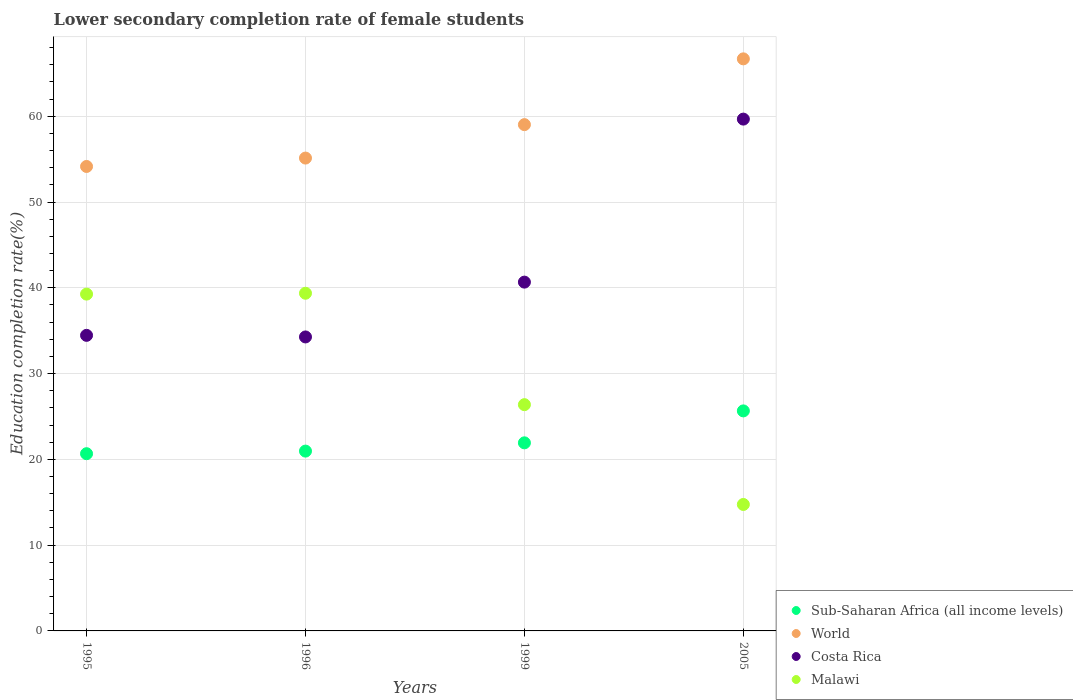Is the number of dotlines equal to the number of legend labels?
Your response must be concise. Yes. What is the lower secondary completion rate of female students in Costa Rica in 1995?
Offer a very short reply. 34.46. Across all years, what is the maximum lower secondary completion rate of female students in Costa Rica?
Your answer should be very brief. 59.67. Across all years, what is the minimum lower secondary completion rate of female students in Sub-Saharan Africa (all income levels)?
Your answer should be very brief. 20.66. In which year was the lower secondary completion rate of female students in Costa Rica maximum?
Make the answer very short. 2005. In which year was the lower secondary completion rate of female students in World minimum?
Ensure brevity in your answer.  1995. What is the total lower secondary completion rate of female students in Sub-Saharan Africa (all income levels) in the graph?
Your response must be concise. 89.2. What is the difference between the lower secondary completion rate of female students in World in 1995 and that in 1996?
Offer a very short reply. -0.98. What is the difference between the lower secondary completion rate of female students in Sub-Saharan Africa (all income levels) in 1995 and the lower secondary completion rate of female students in Costa Rica in 1996?
Your response must be concise. -13.61. What is the average lower secondary completion rate of female students in Malawi per year?
Provide a succinct answer. 29.94. In the year 1995, what is the difference between the lower secondary completion rate of female students in World and lower secondary completion rate of female students in Sub-Saharan Africa (all income levels)?
Offer a terse response. 33.49. In how many years, is the lower secondary completion rate of female students in Malawi greater than 14 %?
Offer a terse response. 4. What is the ratio of the lower secondary completion rate of female students in Malawi in 1995 to that in 2005?
Offer a very short reply. 2.66. What is the difference between the highest and the second highest lower secondary completion rate of female students in Malawi?
Give a very brief answer. 0.1. What is the difference between the highest and the lowest lower secondary completion rate of female students in World?
Provide a succinct answer. 12.54. In how many years, is the lower secondary completion rate of female students in Sub-Saharan Africa (all income levels) greater than the average lower secondary completion rate of female students in Sub-Saharan Africa (all income levels) taken over all years?
Give a very brief answer. 1. Is the sum of the lower secondary completion rate of female students in Malawi in 1995 and 2005 greater than the maximum lower secondary completion rate of female students in Sub-Saharan Africa (all income levels) across all years?
Offer a terse response. Yes. Is the lower secondary completion rate of female students in Malawi strictly greater than the lower secondary completion rate of female students in World over the years?
Provide a succinct answer. No. How many dotlines are there?
Provide a short and direct response. 4. How many years are there in the graph?
Your response must be concise. 4. Does the graph contain any zero values?
Give a very brief answer. No. Does the graph contain grids?
Provide a succinct answer. Yes. Where does the legend appear in the graph?
Offer a very short reply. Bottom right. How many legend labels are there?
Your answer should be compact. 4. What is the title of the graph?
Give a very brief answer. Lower secondary completion rate of female students. What is the label or title of the Y-axis?
Your answer should be very brief. Education completion rate(%). What is the Education completion rate(%) in Sub-Saharan Africa (all income levels) in 1995?
Offer a terse response. 20.66. What is the Education completion rate(%) of World in 1995?
Make the answer very short. 54.15. What is the Education completion rate(%) of Costa Rica in 1995?
Offer a very short reply. 34.46. What is the Education completion rate(%) in Malawi in 1995?
Your answer should be compact. 39.27. What is the Education completion rate(%) of Sub-Saharan Africa (all income levels) in 1996?
Make the answer very short. 20.96. What is the Education completion rate(%) in World in 1996?
Offer a very short reply. 55.13. What is the Education completion rate(%) in Costa Rica in 1996?
Provide a succinct answer. 34.27. What is the Education completion rate(%) of Malawi in 1996?
Make the answer very short. 39.37. What is the Education completion rate(%) of Sub-Saharan Africa (all income levels) in 1999?
Give a very brief answer. 21.93. What is the Education completion rate(%) of World in 1999?
Offer a very short reply. 59.02. What is the Education completion rate(%) of Costa Rica in 1999?
Your answer should be very brief. 40.66. What is the Education completion rate(%) in Malawi in 1999?
Provide a short and direct response. 26.38. What is the Education completion rate(%) of Sub-Saharan Africa (all income levels) in 2005?
Keep it short and to the point. 25.65. What is the Education completion rate(%) in World in 2005?
Offer a very short reply. 66.69. What is the Education completion rate(%) of Costa Rica in 2005?
Your answer should be very brief. 59.67. What is the Education completion rate(%) of Malawi in 2005?
Ensure brevity in your answer.  14.74. Across all years, what is the maximum Education completion rate(%) in Sub-Saharan Africa (all income levels)?
Offer a terse response. 25.65. Across all years, what is the maximum Education completion rate(%) of World?
Offer a very short reply. 66.69. Across all years, what is the maximum Education completion rate(%) of Costa Rica?
Ensure brevity in your answer.  59.67. Across all years, what is the maximum Education completion rate(%) in Malawi?
Keep it short and to the point. 39.37. Across all years, what is the minimum Education completion rate(%) of Sub-Saharan Africa (all income levels)?
Make the answer very short. 20.66. Across all years, what is the minimum Education completion rate(%) in World?
Provide a succinct answer. 54.15. Across all years, what is the minimum Education completion rate(%) of Costa Rica?
Your answer should be very brief. 34.27. Across all years, what is the minimum Education completion rate(%) of Malawi?
Ensure brevity in your answer.  14.74. What is the total Education completion rate(%) of Sub-Saharan Africa (all income levels) in the graph?
Make the answer very short. 89.2. What is the total Education completion rate(%) of World in the graph?
Your answer should be very brief. 234.99. What is the total Education completion rate(%) in Costa Rica in the graph?
Provide a succinct answer. 169.06. What is the total Education completion rate(%) of Malawi in the graph?
Your response must be concise. 119.75. What is the difference between the Education completion rate(%) of Sub-Saharan Africa (all income levels) in 1995 and that in 1996?
Make the answer very short. -0.3. What is the difference between the Education completion rate(%) of World in 1995 and that in 1996?
Provide a short and direct response. -0.98. What is the difference between the Education completion rate(%) of Costa Rica in 1995 and that in 1996?
Give a very brief answer. 0.18. What is the difference between the Education completion rate(%) of Malawi in 1995 and that in 1996?
Provide a short and direct response. -0.1. What is the difference between the Education completion rate(%) in Sub-Saharan Africa (all income levels) in 1995 and that in 1999?
Ensure brevity in your answer.  -1.27. What is the difference between the Education completion rate(%) of World in 1995 and that in 1999?
Provide a succinct answer. -4.88. What is the difference between the Education completion rate(%) of Costa Rica in 1995 and that in 1999?
Your response must be concise. -6.21. What is the difference between the Education completion rate(%) of Malawi in 1995 and that in 1999?
Provide a succinct answer. 12.89. What is the difference between the Education completion rate(%) of Sub-Saharan Africa (all income levels) in 1995 and that in 2005?
Provide a short and direct response. -4.99. What is the difference between the Education completion rate(%) of World in 1995 and that in 2005?
Give a very brief answer. -12.54. What is the difference between the Education completion rate(%) in Costa Rica in 1995 and that in 2005?
Your answer should be compact. -25.21. What is the difference between the Education completion rate(%) in Malawi in 1995 and that in 2005?
Make the answer very short. 24.52. What is the difference between the Education completion rate(%) in Sub-Saharan Africa (all income levels) in 1996 and that in 1999?
Offer a very short reply. -0.96. What is the difference between the Education completion rate(%) in World in 1996 and that in 1999?
Ensure brevity in your answer.  -3.9. What is the difference between the Education completion rate(%) in Costa Rica in 1996 and that in 1999?
Make the answer very short. -6.39. What is the difference between the Education completion rate(%) of Malawi in 1996 and that in 1999?
Provide a short and direct response. 12.99. What is the difference between the Education completion rate(%) of Sub-Saharan Africa (all income levels) in 1996 and that in 2005?
Offer a terse response. -4.69. What is the difference between the Education completion rate(%) in World in 1996 and that in 2005?
Your response must be concise. -11.57. What is the difference between the Education completion rate(%) of Costa Rica in 1996 and that in 2005?
Ensure brevity in your answer.  -25.4. What is the difference between the Education completion rate(%) of Malawi in 1996 and that in 2005?
Your response must be concise. 24.62. What is the difference between the Education completion rate(%) in Sub-Saharan Africa (all income levels) in 1999 and that in 2005?
Your response must be concise. -3.72. What is the difference between the Education completion rate(%) of World in 1999 and that in 2005?
Your answer should be very brief. -7.67. What is the difference between the Education completion rate(%) of Costa Rica in 1999 and that in 2005?
Make the answer very short. -19. What is the difference between the Education completion rate(%) of Malawi in 1999 and that in 2005?
Keep it short and to the point. 11.64. What is the difference between the Education completion rate(%) in Sub-Saharan Africa (all income levels) in 1995 and the Education completion rate(%) in World in 1996?
Your answer should be compact. -34.47. What is the difference between the Education completion rate(%) in Sub-Saharan Africa (all income levels) in 1995 and the Education completion rate(%) in Costa Rica in 1996?
Provide a succinct answer. -13.61. What is the difference between the Education completion rate(%) in Sub-Saharan Africa (all income levels) in 1995 and the Education completion rate(%) in Malawi in 1996?
Give a very brief answer. -18.71. What is the difference between the Education completion rate(%) of World in 1995 and the Education completion rate(%) of Costa Rica in 1996?
Ensure brevity in your answer.  19.88. What is the difference between the Education completion rate(%) of World in 1995 and the Education completion rate(%) of Malawi in 1996?
Keep it short and to the point. 14.78. What is the difference between the Education completion rate(%) in Costa Rica in 1995 and the Education completion rate(%) in Malawi in 1996?
Your answer should be very brief. -4.91. What is the difference between the Education completion rate(%) of Sub-Saharan Africa (all income levels) in 1995 and the Education completion rate(%) of World in 1999?
Your response must be concise. -38.36. What is the difference between the Education completion rate(%) of Sub-Saharan Africa (all income levels) in 1995 and the Education completion rate(%) of Costa Rica in 1999?
Make the answer very short. -20. What is the difference between the Education completion rate(%) in Sub-Saharan Africa (all income levels) in 1995 and the Education completion rate(%) in Malawi in 1999?
Your answer should be compact. -5.72. What is the difference between the Education completion rate(%) of World in 1995 and the Education completion rate(%) of Costa Rica in 1999?
Ensure brevity in your answer.  13.48. What is the difference between the Education completion rate(%) in World in 1995 and the Education completion rate(%) in Malawi in 1999?
Ensure brevity in your answer.  27.77. What is the difference between the Education completion rate(%) in Costa Rica in 1995 and the Education completion rate(%) in Malawi in 1999?
Provide a succinct answer. 8.08. What is the difference between the Education completion rate(%) of Sub-Saharan Africa (all income levels) in 1995 and the Education completion rate(%) of World in 2005?
Give a very brief answer. -46.03. What is the difference between the Education completion rate(%) in Sub-Saharan Africa (all income levels) in 1995 and the Education completion rate(%) in Costa Rica in 2005?
Give a very brief answer. -39.01. What is the difference between the Education completion rate(%) in Sub-Saharan Africa (all income levels) in 1995 and the Education completion rate(%) in Malawi in 2005?
Offer a terse response. 5.92. What is the difference between the Education completion rate(%) of World in 1995 and the Education completion rate(%) of Costa Rica in 2005?
Offer a terse response. -5.52. What is the difference between the Education completion rate(%) in World in 1995 and the Education completion rate(%) in Malawi in 2005?
Keep it short and to the point. 39.41. What is the difference between the Education completion rate(%) of Costa Rica in 1995 and the Education completion rate(%) of Malawi in 2005?
Your answer should be very brief. 19.72. What is the difference between the Education completion rate(%) in Sub-Saharan Africa (all income levels) in 1996 and the Education completion rate(%) in World in 1999?
Your answer should be very brief. -38.06. What is the difference between the Education completion rate(%) of Sub-Saharan Africa (all income levels) in 1996 and the Education completion rate(%) of Costa Rica in 1999?
Keep it short and to the point. -19.7. What is the difference between the Education completion rate(%) in Sub-Saharan Africa (all income levels) in 1996 and the Education completion rate(%) in Malawi in 1999?
Your answer should be very brief. -5.41. What is the difference between the Education completion rate(%) of World in 1996 and the Education completion rate(%) of Costa Rica in 1999?
Give a very brief answer. 14.46. What is the difference between the Education completion rate(%) in World in 1996 and the Education completion rate(%) in Malawi in 1999?
Keep it short and to the point. 28.75. What is the difference between the Education completion rate(%) in Costa Rica in 1996 and the Education completion rate(%) in Malawi in 1999?
Give a very brief answer. 7.89. What is the difference between the Education completion rate(%) of Sub-Saharan Africa (all income levels) in 1996 and the Education completion rate(%) of World in 2005?
Your answer should be compact. -45.73. What is the difference between the Education completion rate(%) in Sub-Saharan Africa (all income levels) in 1996 and the Education completion rate(%) in Costa Rica in 2005?
Give a very brief answer. -38.7. What is the difference between the Education completion rate(%) of Sub-Saharan Africa (all income levels) in 1996 and the Education completion rate(%) of Malawi in 2005?
Offer a very short reply. 6.22. What is the difference between the Education completion rate(%) of World in 1996 and the Education completion rate(%) of Costa Rica in 2005?
Your response must be concise. -4.54. What is the difference between the Education completion rate(%) of World in 1996 and the Education completion rate(%) of Malawi in 2005?
Provide a short and direct response. 40.38. What is the difference between the Education completion rate(%) of Costa Rica in 1996 and the Education completion rate(%) of Malawi in 2005?
Offer a very short reply. 19.53. What is the difference between the Education completion rate(%) of Sub-Saharan Africa (all income levels) in 1999 and the Education completion rate(%) of World in 2005?
Your response must be concise. -44.77. What is the difference between the Education completion rate(%) in Sub-Saharan Africa (all income levels) in 1999 and the Education completion rate(%) in Costa Rica in 2005?
Your answer should be compact. -37.74. What is the difference between the Education completion rate(%) of Sub-Saharan Africa (all income levels) in 1999 and the Education completion rate(%) of Malawi in 2005?
Your response must be concise. 7.18. What is the difference between the Education completion rate(%) in World in 1999 and the Education completion rate(%) in Costa Rica in 2005?
Offer a terse response. -0.64. What is the difference between the Education completion rate(%) in World in 1999 and the Education completion rate(%) in Malawi in 2005?
Provide a short and direct response. 44.28. What is the difference between the Education completion rate(%) of Costa Rica in 1999 and the Education completion rate(%) of Malawi in 2005?
Keep it short and to the point. 25.92. What is the average Education completion rate(%) of Sub-Saharan Africa (all income levels) per year?
Offer a terse response. 22.3. What is the average Education completion rate(%) of World per year?
Your answer should be very brief. 58.75. What is the average Education completion rate(%) of Costa Rica per year?
Provide a succinct answer. 42.27. What is the average Education completion rate(%) in Malawi per year?
Give a very brief answer. 29.94. In the year 1995, what is the difference between the Education completion rate(%) of Sub-Saharan Africa (all income levels) and Education completion rate(%) of World?
Make the answer very short. -33.49. In the year 1995, what is the difference between the Education completion rate(%) of Sub-Saharan Africa (all income levels) and Education completion rate(%) of Costa Rica?
Ensure brevity in your answer.  -13.8. In the year 1995, what is the difference between the Education completion rate(%) of Sub-Saharan Africa (all income levels) and Education completion rate(%) of Malawi?
Ensure brevity in your answer.  -18.61. In the year 1995, what is the difference between the Education completion rate(%) in World and Education completion rate(%) in Costa Rica?
Offer a terse response. 19.69. In the year 1995, what is the difference between the Education completion rate(%) in World and Education completion rate(%) in Malawi?
Your response must be concise. 14.88. In the year 1995, what is the difference between the Education completion rate(%) of Costa Rica and Education completion rate(%) of Malawi?
Ensure brevity in your answer.  -4.81. In the year 1996, what is the difference between the Education completion rate(%) of Sub-Saharan Africa (all income levels) and Education completion rate(%) of World?
Make the answer very short. -34.16. In the year 1996, what is the difference between the Education completion rate(%) in Sub-Saharan Africa (all income levels) and Education completion rate(%) in Costa Rica?
Your answer should be very brief. -13.31. In the year 1996, what is the difference between the Education completion rate(%) of Sub-Saharan Africa (all income levels) and Education completion rate(%) of Malawi?
Give a very brief answer. -18.4. In the year 1996, what is the difference between the Education completion rate(%) in World and Education completion rate(%) in Costa Rica?
Provide a succinct answer. 20.85. In the year 1996, what is the difference between the Education completion rate(%) in World and Education completion rate(%) in Malawi?
Your response must be concise. 15.76. In the year 1996, what is the difference between the Education completion rate(%) of Costa Rica and Education completion rate(%) of Malawi?
Keep it short and to the point. -5.09. In the year 1999, what is the difference between the Education completion rate(%) in Sub-Saharan Africa (all income levels) and Education completion rate(%) in World?
Make the answer very short. -37.1. In the year 1999, what is the difference between the Education completion rate(%) in Sub-Saharan Africa (all income levels) and Education completion rate(%) in Costa Rica?
Keep it short and to the point. -18.74. In the year 1999, what is the difference between the Education completion rate(%) of Sub-Saharan Africa (all income levels) and Education completion rate(%) of Malawi?
Keep it short and to the point. -4.45. In the year 1999, what is the difference between the Education completion rate(%) of World and Education completion rate(%) of Costa Rica?
Make the answer very short. 18.36. In the year 1999, what is the difference between the Education completion rate(%) in World and Education completion rate(%) in Malawi?
Offer a terse response. 32.65. In the year 1999, what is the difference between the Education completion rate(%) of Costa Rica and Education completion rate(%) of Malawi?
Your response must be concise. 14.29. In the year 2005, what is the difference between the Education completion rate(%) in Sub-Saharan Africa (all income levels) and Education completion rate(%) in World?
Your response must be concise. -41.04. In the year 2005, what is the difference between the Education completion rate(%) in Sub-Saharan Africa (all income levels) and Education completion rate(%) in Costa Rica?
Your answer should be compact. -34.02. In the year 2005, what is the difference between the Education completion rate(%) in Sub-Saharan Africa (all income levels) and Education completion rate(%) in Malawi?
Give a very brief answer. 10.91. In the year 2005, what is the difference between the Education completion rate(%) in World and Education completion rate(%) in Costa Rica?
Keep it short and to the point. 7.02. In the year 2005, what is the difference between the Education completion rate(%) of World and Education completion rate(%) of Malawi?
Provide a succinct answer. 51.95. In the year 2005, what is the difference between the Education completion rate(%) of Costa Rica and Education completion rate(%) of Malawi?
Offer a very short reply. 44.93. What is the ratio of the Education completion rate(%) of Sub-Saharan Africa (all income levels) in 1995 to that in 1996?
Your answer should be very brief. 0.99. What is the ratio of the Education completion rate(%) of World in 1995 to that in 1996?
Provide a succinct answer. 0.98. What is the ratio of the Education completion rate(%) of Costa Rica in 1995 to that in 1996?
Give a very brief answer. 1.01. What is the ratio of the Education completion rate(%) in Sub-Saharan Africa (all income levels) in 1995 to that in 1999?
Make the answer very short. 0.94. What is the ratio of the Education completion rate(%) of World in 1995 to that in 1999?
Your response must be concise. 0.92. What is the ratio of the Education completion rate(%) of Costa Rica in 1995 to that in 1999?
Ensure brevity in your answer.  0.85. What is the ratio of the Education completion rate(%) of Malawi in 1995 to that in 1999?
Offer a very short reply. 1.49. What is the ratio of the Education completion rate(%) of Sub-Saharan Africa (all income levels) in 1995 to that in 2005?
Your answer should be compact. 0.81. What is the ratio of the Education completion rate(%) of World in 1995 to that in 2005?
Your answer should be very brief. 0.81. What is the ratio of the Education completion rate(%) of Costa Rica in 1995 to that in 2005?
Offer a very short reply. 0.58. What is the ratio of the Education completion rate(%) of Malawi in 1995 to that in 2005?
Provide a short and direct response. 2.66. What is the ratio of the Education completion rate(%) of Sub-Saharan Africa (all income levels) in 1996 to that in 1999?
Ensure brevity in your answer.  0.96. What is the ratio of the Education completion rate(%) of World in 1996 to that in 1999?
Make the answer very short. 0.93. What is the ratio of the Education completion rate(%) in Costa Rica in 1996 to that in 1999?
Your response must be concise. 0.84. What is the ratio of the Education completion rate(%) in Malawi in 1996 to that in 1999?
Offer a terse response. 1.49. What is the ratio of the Education completion rate(%) of Sub-Saharan Africa (all income levels) in 1996 to that in 2005?
Give a very brief answer. 0.82. What is the ratio of the Education completion rate(%) in World in 1996 to that in 2005?
Give a very brief answer. 0.83. What is the ratio of the Education completion rate(%) in Costa Rica in 1996 to that in 2005?
Offer a terse response. 0.57. What is the ratio of the Education completion rate(%) in Malawi in 1996 to that in 2005?
Your response must be concise. 2.67. What is the ratio of the Education completion rate(%) of Sub-Saharan Africa (all income levels) in 1999 to that in 2005?
Make the answer very short. 0.85. What is the ratio of the Education completion rate(%) of World in 1999 to that in 2005?
Provide a short and direct response. 0.89. What is the ratio of the Education completion rate(%) of Costa Rica in 1999 to that in 2005?
Your answer should be compact. 0.68. What is the ratio of the Education completion rate(%) in Malawi in 1999 to that in 2005?
Give a very brief answer. 1.79. What is the difference between the highest and the second highest Education completion rate(%) in Sub-Saharan Africa (all income levels)?
Ensure brevity in your answer.  3.72. What is the difference between the highest and the second highest Education completion rate(%) in World?
Your answer should be compact. 7.67. What is the difference between the highest and the second highest Education completion rate(%) in Costa Rica?
Your response must be concise. 19. What is the difference between the highest and the second highest Education completion rate(%) in Malawi?
Ensure brevity in your answer.  0.1. What is the difference between the highest and the lowest Education completion rate(%) of Sub-Saharan Africa (all income levels)?
Ensure brevity in your answer.  4.99. What is the difference between the highest and the lowest Education completion rate(%) of World?
Provide a succinct answer. 12.54. What is the difference between the highest and the lowest Education completion rate(%) of Costa Rica?
Make the answer very short. 25.4. What is the difference between the highest and the lowest Education completion rate(%) in Malawi?
Your answer should be very brief. 24.62. 